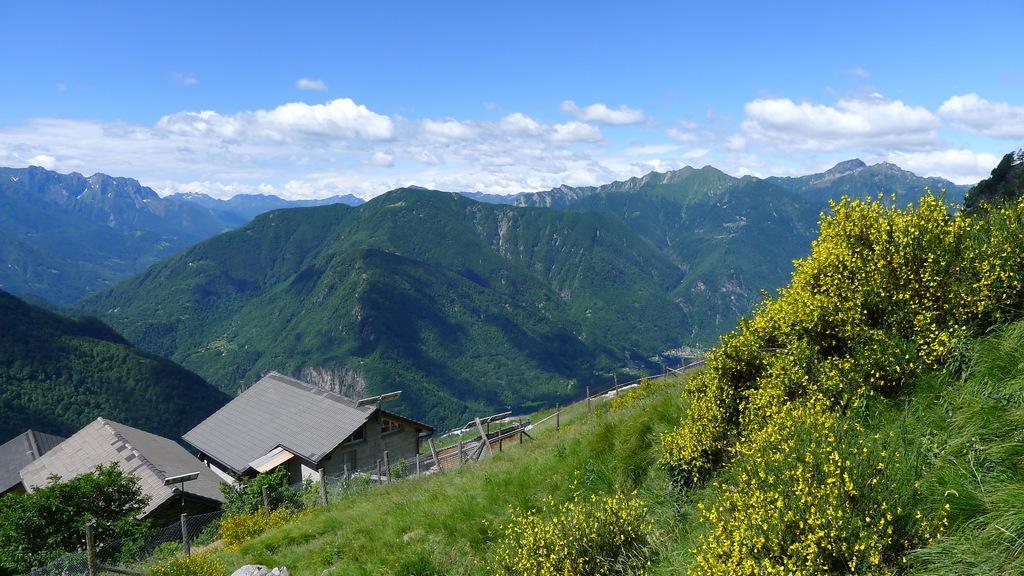How would you summarize this image in a sentence or two? In this picture I can see many mountains. In the bottom left I can see some wooden sheds. In the bottom left corner I can see the fencing. On the right I can see some yellow flowers on the plants. Beside that I can see the grass. At the top I can see the sky and clouds. 